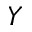<formula> <loc_0><loc_0><loc_500><loc_500>Y</formula> 